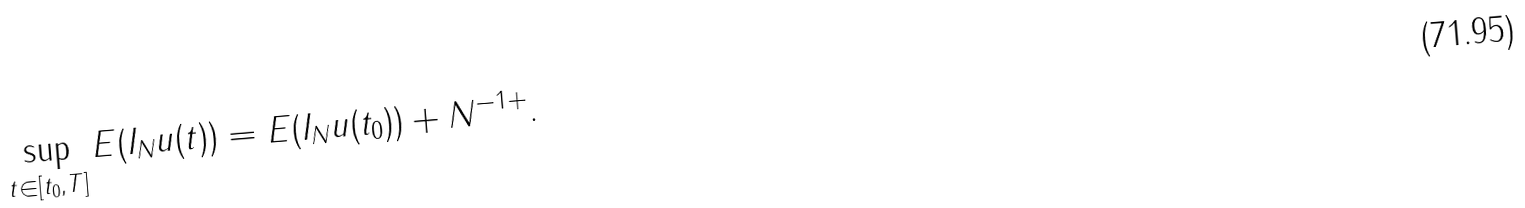<formula> <loc_0><loc_0><loc_500><loc_500>\sup _ { t \in [ t _ { 0 } , T ] } E ( I _ { N } u ( t ) ) = E ( I _ { N } u ( t _ { 0 } ) ) + N ^ { - 1 + } .</formula> 